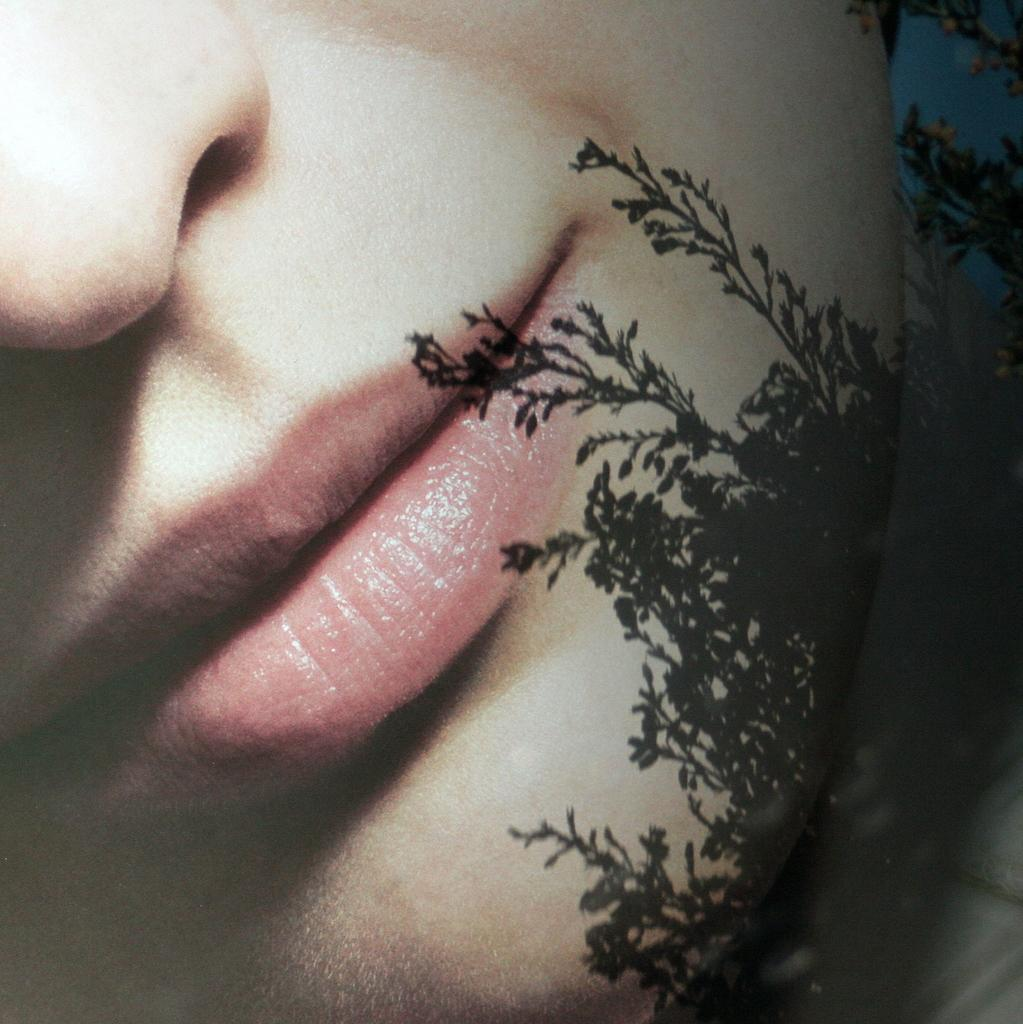What can be observed about the image's appearance? The image is edited. What part of a person can be seen in the image? The head of a person is visible in the image. What flavor of ice cream is being held by the person in the image? There is no ice cream visible in the image, and the person's hands are not shown, so it is impossible to determine the flavor of any ice cream they might be holding. 